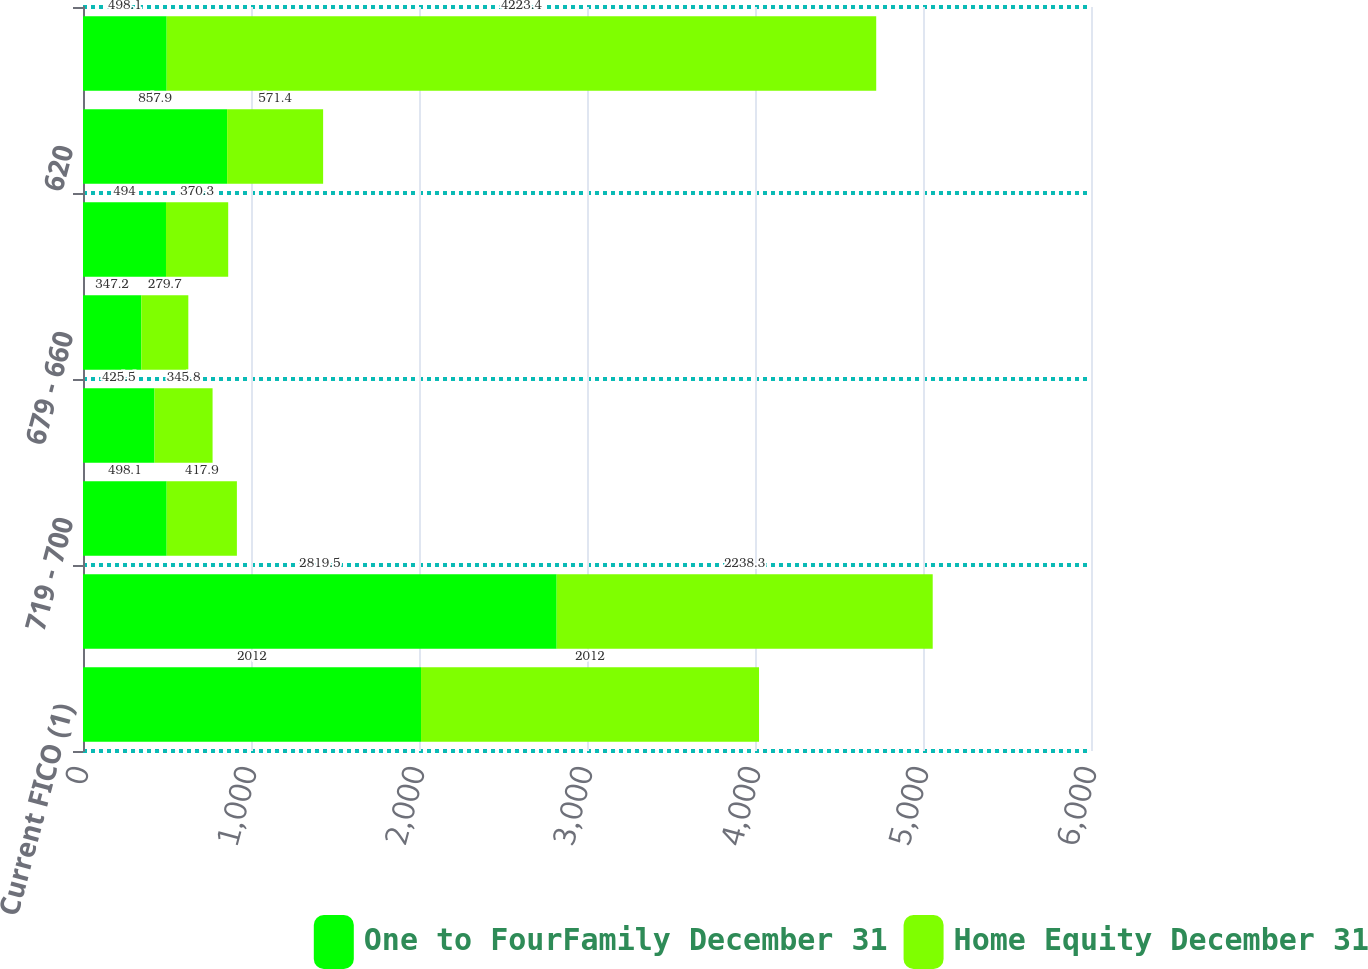Convert chart to OTSL. <chart><loc_0><loc_0><loc_500><loc_500><stacked_bar_chart><ecel><fcel>Current FICO (1)<fcel>=720<fcel>719 - 700<fcel>699 - 680<fcel>679 - 660<fcel>659 - 620<fcel>620<fcel>Total mortgage loans<nl><fcel>One to FourFamily December 31<fcel>2012<fcel>2819.5<fcel>498.1<fcel>425.5<fcel>347.2<fcel>494<fcel>857.9<fcel>498.1<nl><fcel>Home Equity December 31<fcel>2012<fcel>2238.3<fcel>417.9<fcel>345.8<fcel>279.7<fcel>370.3<fcel>571.4<fcel>4223.4<nl></chart> 